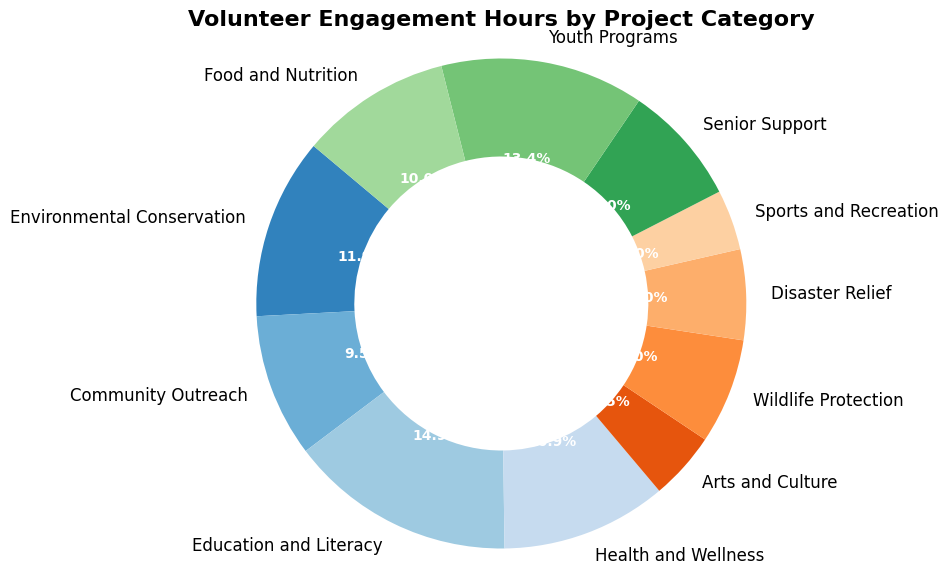What percentage of volunteer hours is dedicated to Education and Literacy? To find the percentage, look directly at the pie chart segment labeled "Education and Literacy" and note the percentage value displayed.
Answer: 22.0% How does the total volunteer hours for Health and Wellness compare to Food and Nutrition? Compare the pie chart segments labeled "Health and Wellness" and "Food and Nutrition". The sizes of the segments represent the total hours, and their percentage values are given.
Answer: Health and Wellness is 15.0% and Food and Nutrition is 14.7% What is the combined percentage of volunteer hours for Environmental Conservation and Youth Programs? First, find the percentages for Environmental Conservation (17.4%) and Youth Programs (7.9%) from the pie chart. Then add these percentages together: 17.4% + 7.9%.
Answer: 25.3% Which project category has the least engagement hours, and what is its percentage? Identify the smallest pie chart segment to find the category with the least hours. The percentage is also labeled on the segment.
Answer: Sports and Recreation, 4.6% Is the percentage of volunteer hours for Senior Support greater than for Sports and Recreation? Compare the labeled percentages of the pie chart segments for "Senior Support" and "Sports and Recreation".
Answer: Yes What is the total percentage of volunteer hours allocated to Arts and Culture, Disaster Relief, and Wildlife Protection combined? Find the percentages from the pie chart for Arts and Culture (6.6%), Disaster Relief (8.8%), and Wildlife Protection (6.3%) and add them together: 6.6% + 8.8% + 6.3%.
Answer: 21.7% Which project category has closest engagement hours to Community Outreach, and what is its percentage? Locate the segment for Community Outreach (13.8%) and identify the segment with the percentage value nearest to it by visual comparison.
Answer: Youth Programs, 20.1% What fraction of the total volunteer hours does Education and Literacy represent? Identify the percentage of Education and Literacy (22.0%) and express it as a fraction of 100.
Answer: 22/100 Is the percentage of hours for Disaster Relief greater than that for Wildlife Protection? Compare the labeled percentages of the pie chart segments for Disaster Relief (8.8%) and Wildlife Protection (6.3%).
Answer: Yes How much larger is the percentage of Youth Programs compared to Arts and Culture? Find the pie chart segment for Youth Programs (20.1%) and Arts and Culture (6.6%), then subtract the smaller percentage from the larger one: 20.1% - 6.6%.
Answer: 13.5% 